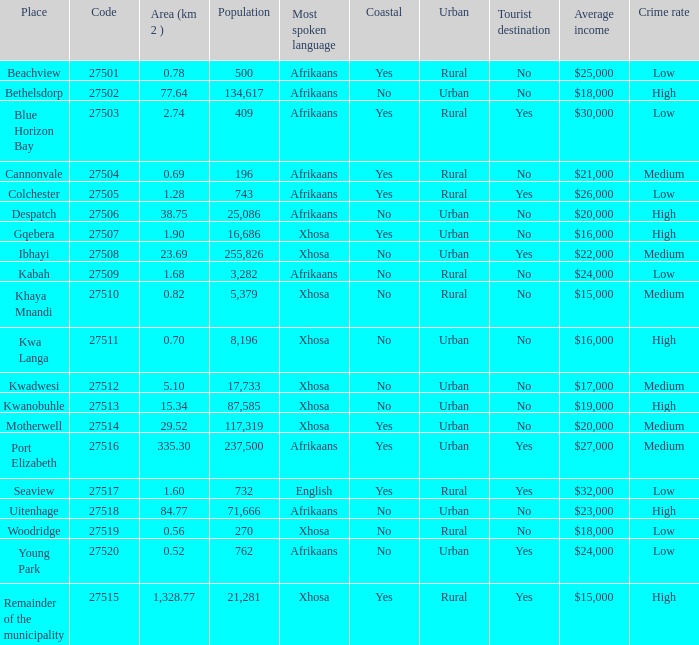What is the lowest code number for the remainder of the municipality that has an area bigger than 15.34 squared kilometers, a population greater than 762 and a language of xhosa spoken? 27515.0. 